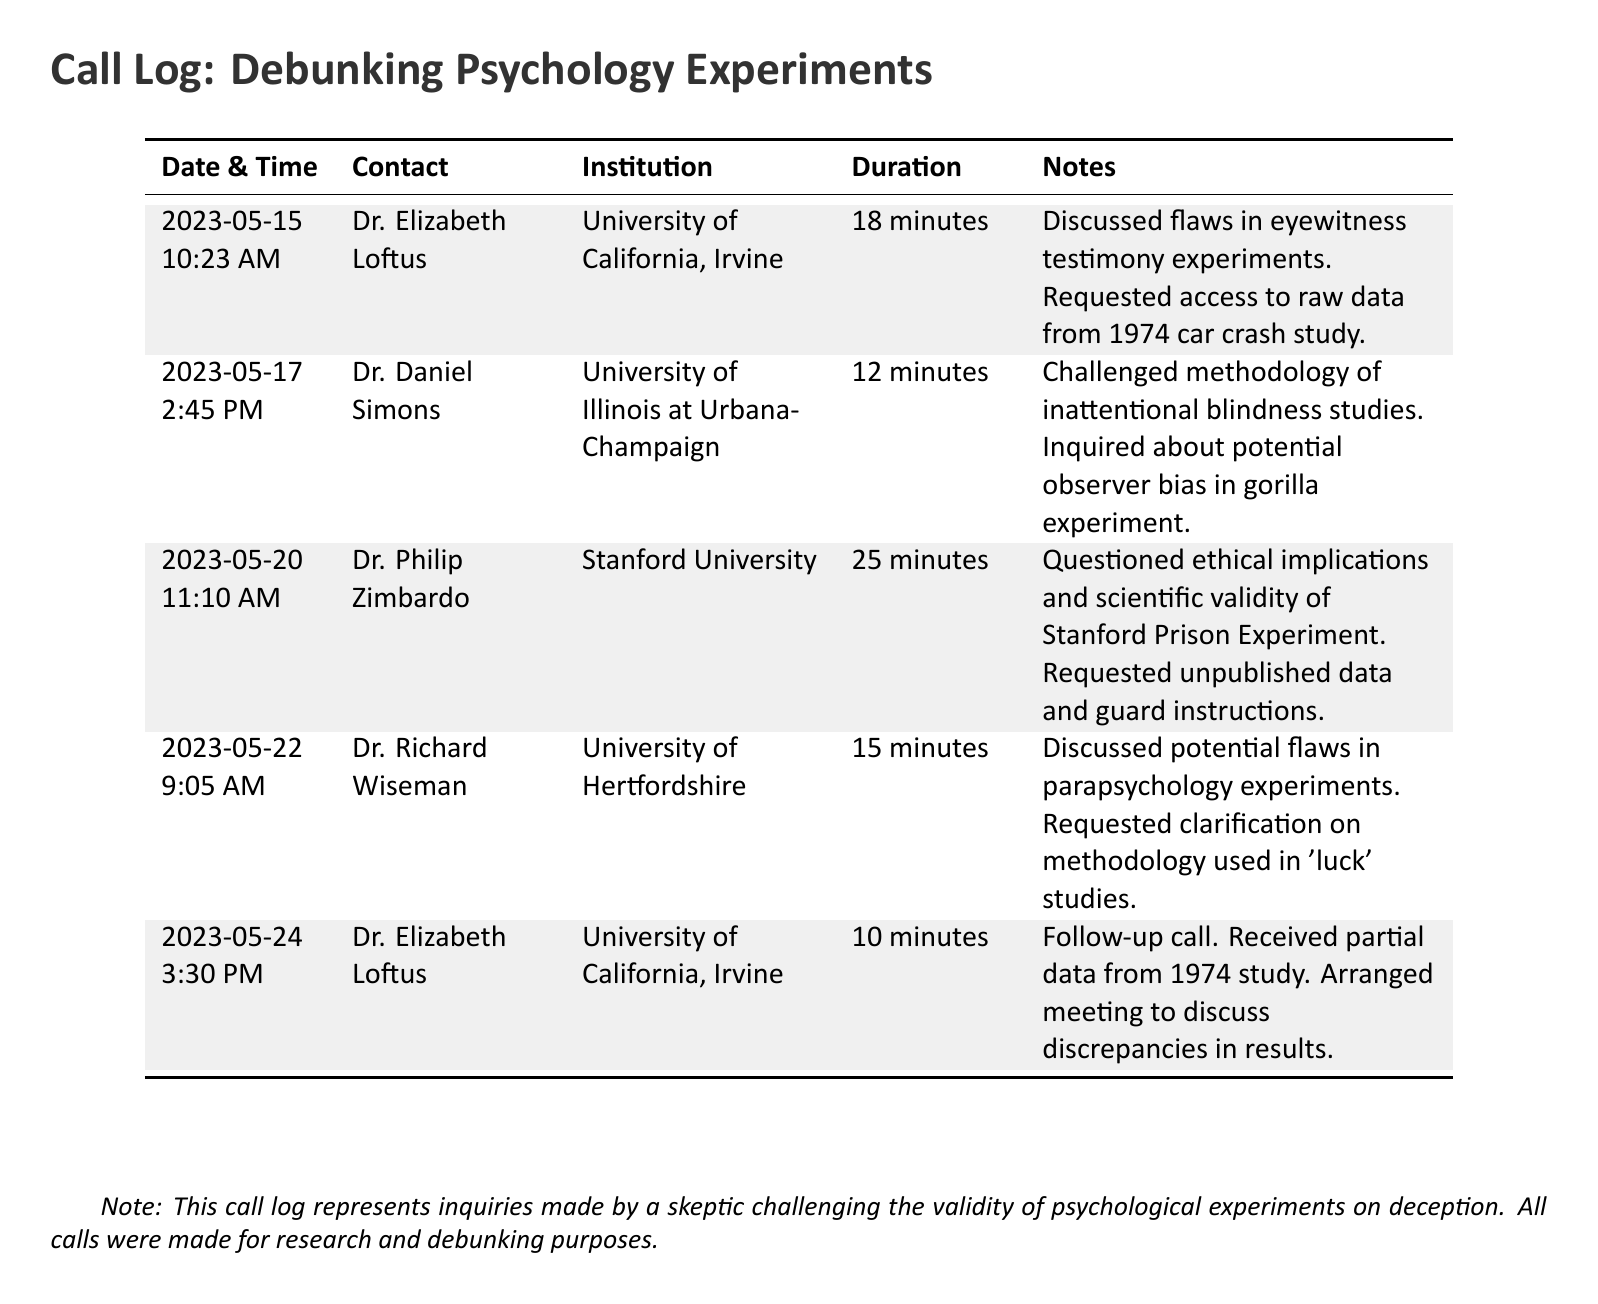What is the duration of the call with Dr. Elizabeth Loftus on May 15? The duration of the call with Dr. Elizabeth Loftus on May 15 is 18 minutes, as stated in the call log.
Answer: 18 minutes Who did the skeptic contact on May 20? The skeptic contacted Dr. Philip Zimbardo from Stanford University on May 20, as listed in the call log.
Answer: Dr. Philip Zimbardo How many minutes did the call with Dr. Richard Wiseman last? The call with Dr. Richard Wiseman lasted 15 minutes, as shown in the document.
Answer: 15 minutes What institution is Dr. Daniel Simons affiliated with? Dr. Daniel Simons is affiliated with the University of Illinois at Urbana-Champaign, which is indicated in the log.
Answer: University of Illinois at Urbana-Champaign What main topic was discussed during the follow-up call with Dr. Elizabeth Loftus? The main topic discussed during the follow-up call with Dr. Elizabeth Loftus was discrepancies in results from the 1974 study, noted in the call.
Answer: Discrepancies in results How many total calls were made according to the log? The total number of calls made according to the log is five, as there are five entries listed.
Answer: Five What was requested from Dr. Philip Zimbardo? The request made to Dr. Philip Zimbardo was for unpublished data and guard instructions, as specified in the notes.
Answer: Unpublished data and guard instructions What color is used for the rows in the call log? The color used for the rows in the call log is light gray, as indicated by the row coloring in the table.
Answer: Light gray What did the skeptic inquire about in relation to the gorilla experiment? The skeptic inquired about potential observer bias in the gorilla experiment, as mentioned in the document.
Answer: Potential observer bias 